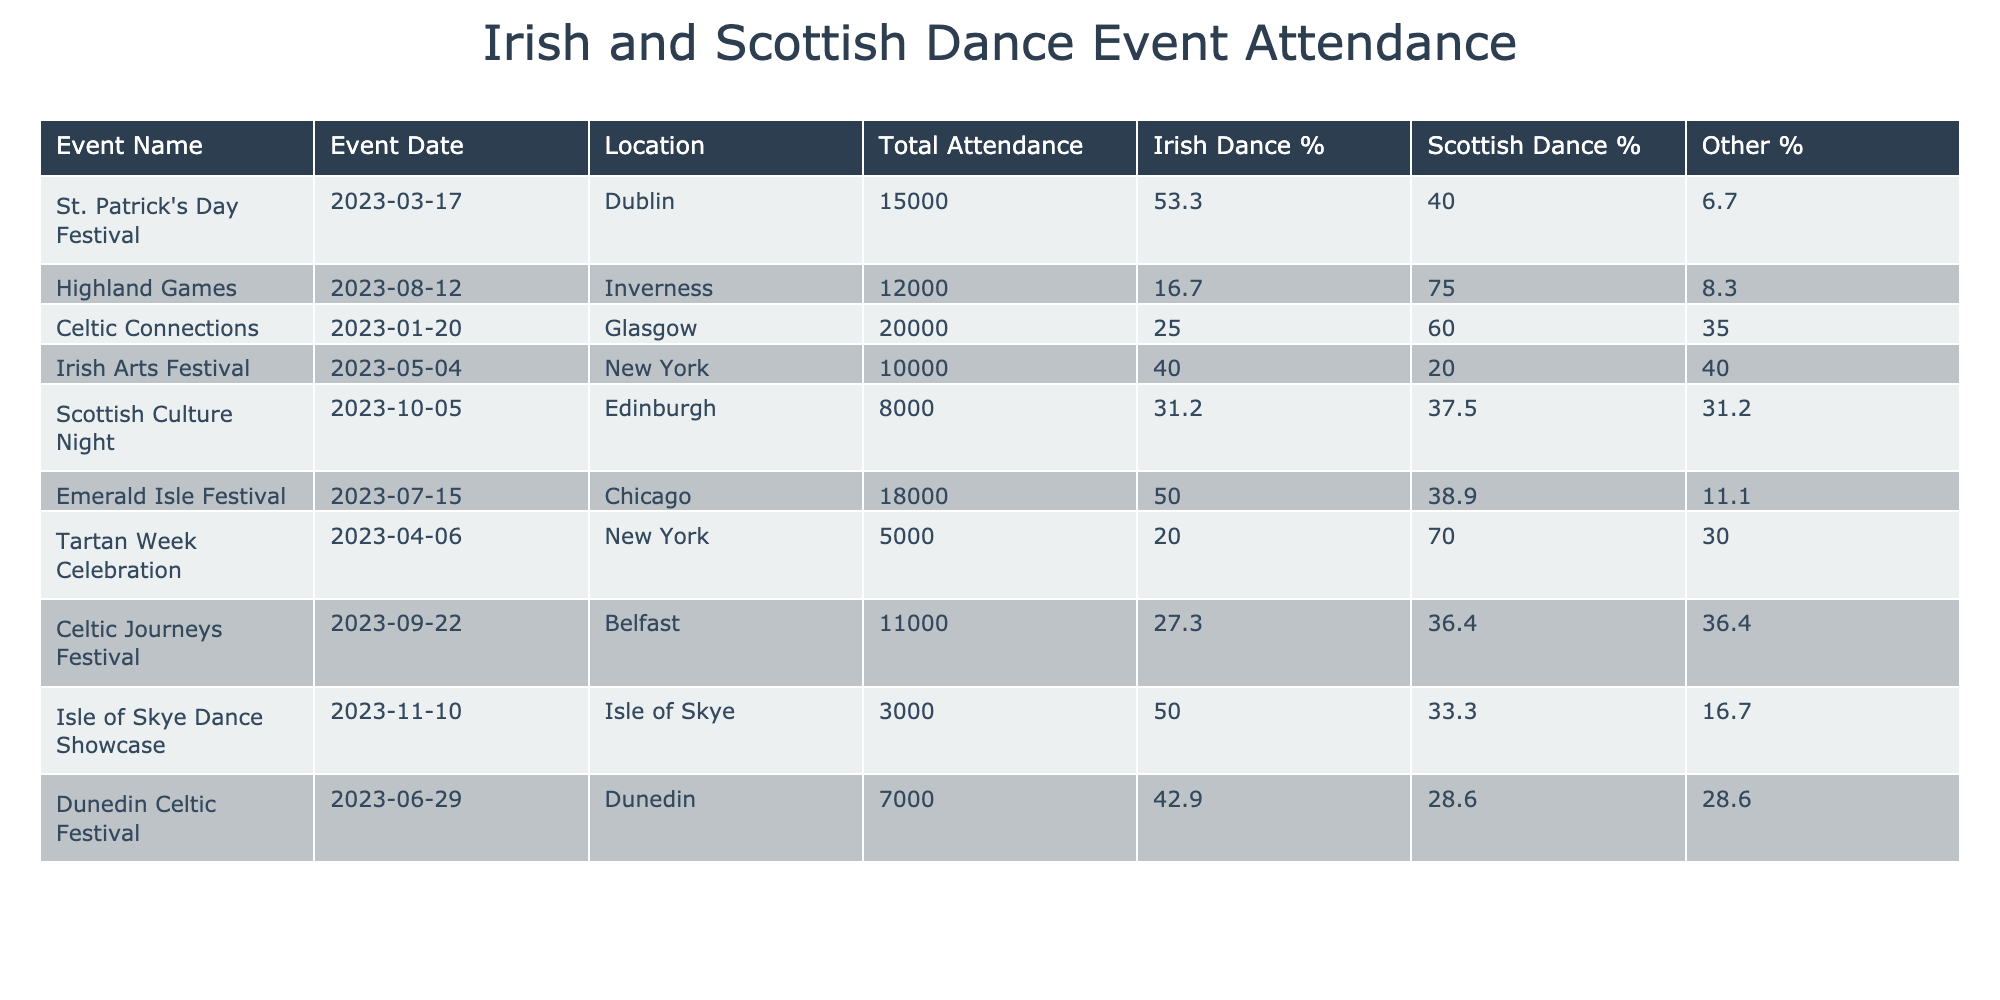What is the location of the Irish Arts Festival? The table lists the Irish Arts Festival under the column for Location. According to the entry for that event, it takes place in New York.
Answer: New York Which event had the highest total attendance? By comparing the Total Attendance column across all events, the Celtic Connections has the highest value at 20000.
Answer: 20000 What percentage of the audience attended the Highland Games event for Scottish dance? The Scottish Dance Attendance for the Highland Games is 9000, and the Total Attendance is 12000. To find the percentage, we use the formula (Scottish Dance Attendance / Total Attendance) * 100, which gives (9000 / 12000) * 100 = 75%.
Answer: 75% How many more people attended this event for Irish dance compared to the Dunedin Celtic Festival? The Irish Dance Attendance for the Highland Games is 2000 and for the Dunedin Celtic Festival is 3000. The difference can be calculated: 3000 - 2000 = 1000.
Answer: 1000 Is the percentage of Other Attendance at the Tartan Week Celebration greater than 20%? The Other Attendance for the Tartan Week Celebration is 1500 and the Total Attendance is 5000. To calculate the percentage, we do (1500 / 5000) * 100 = 30%. Since 30% is greater than 20%, the answer is yes.
Answer: Yes What is the average percentage of Irish dance attendance across all events? First, we find the Irish Dance Attendance percentages for all events: 53.3%, 16.7%, 25%, 40%, 31.3%, 50%, 20%, 27.3%, 50%, and 42.9%. Then, we sum these: 53.3 + 16.7 + 25 + 40 + 31.3 + 50 + 20 + 27.3 + 50 + 42.9 = 357.5. Finally, we divide by the number of events, which is 10, to find the average: 357.5 / 10 = 35.75%.
Answer: 35.75% Which event had the least attendance for Scottish dance, and how many attended? By reviewing the Scottish Dance Attendance across all events, the Isle of Skye Dance Showcase has the lowest attendance at 1000.
Answer: Isle of Skye Dance Showcase, 1000 Are there more events with over 2000 attendance for Irish dance than for Scottish dance? Let's count: Irish Dance attendance over 2000 occurs in St. Patrick's Day Festival, Emerald Isle Festival, and Dunedin Celtic Festival (3 events). Scottish Dance attendance over 2000 occurs in Highland Games, Celtic Connections, and Scottish Culture Night (also 3 events). Since both categories are equal, the answer is no.
Answer: No What was the total attendance for events held in New York? The events in New York are the Irish Arts Festival and Tartan Week Celebration. Their attendance numbers are 10000 and 5000 respectively. Summing these gives: 10000 + 5000 = 15000.
Answer: 15000 